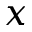Convert formula to latex. <formula><loc_0><loc_0><loc_500><loc_500>x</formula> 